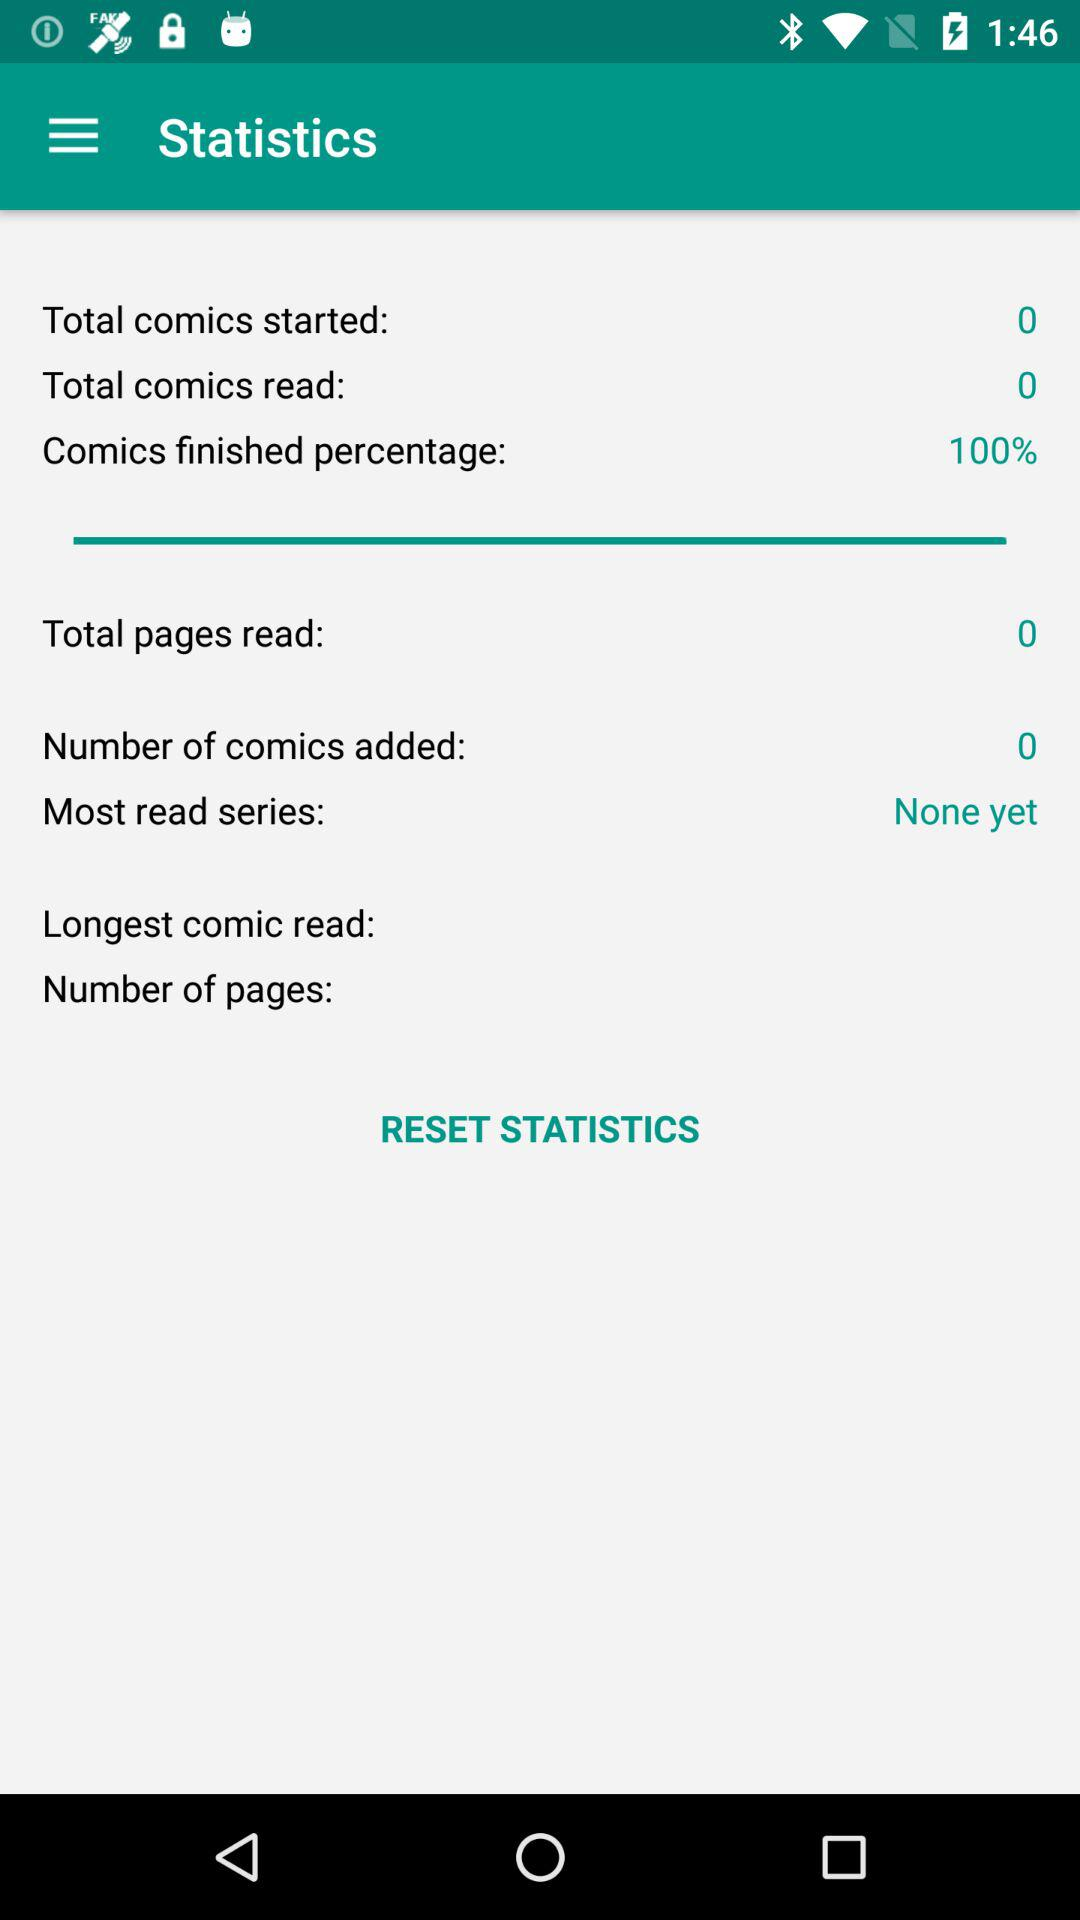What percentage of the comics were finished? The comics were finished 100%. 